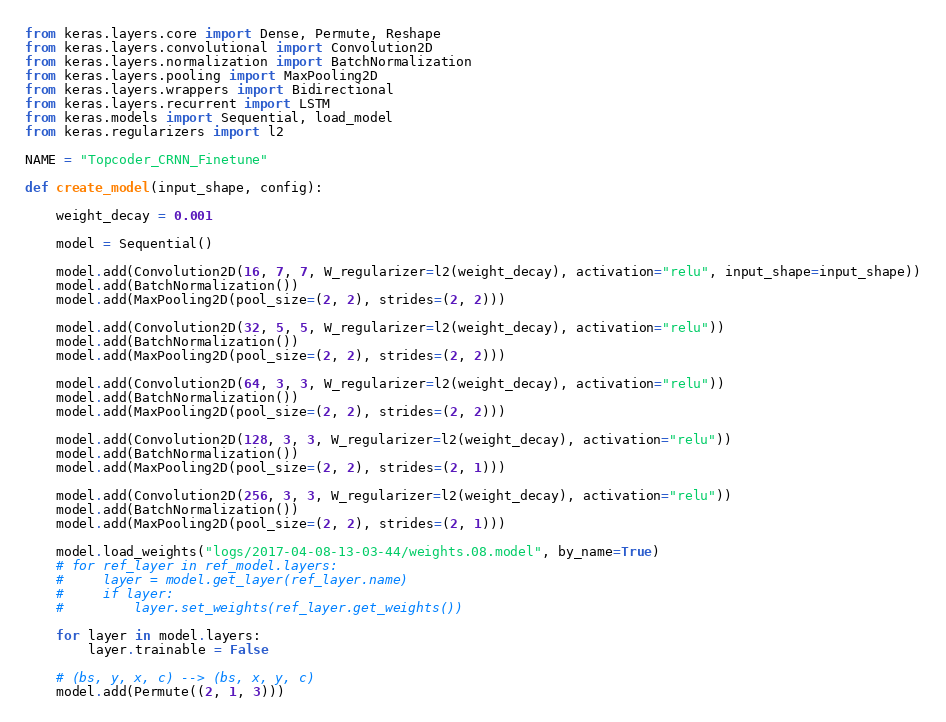Convert code to text. <code><loc_0><loc_0><loc_500><loc_500><_Python_>from keras.layers.core import Dense, Permute, Reshape
from keras.layers.convolutional import Convolution2D
from keras.layers.normalization import BatchNormalization
from keras.layers.pooling import MaxPooling2D
from keras.layers.wrappers import Bidirectional
from keras.layers.recurrent import LSTM
from keras.models import Sequential, load_model
from keras.regularizers import l2

NAME = "Topcoder_CRNN_Finetune"

def create_model(input_shape, config):

    weight_decay = 0.001

    model = Sequential()

    model.add(Convolution2D(16, 7, 7, W_regularizer=l2(weight_decay), activation="relu", input_shape=input_shape))
    model.add(BatchNormalization())
    model.add(MaxPooling2D(pool_size=(2, 2), strides=(2, 2)))

    model.add(Convolution2D(32, 5, 5, W_regularizer=l2(weight_decay), activation="relu"))
    model.add(BatchNormalization())
    model.add(MaxPooling2D(pool_size=(2, 2), strides=(2, 2)))

    model.add(Convolution2D(64, 3, 3, W_regularizer=l2(weight_decay), activation="relu"))
    model.add(BatchNormalization())
    model.add(MaxPooling2D(pool_size=(2, 2), strides=(2, 2)))

    model.add(Convolution2D(128, 3, 3, W_regularizer=l2(weight_decay), activation="relu"))
    model.add(BatchNormalization())
    model.add(MaxPooling2D(pool_size=(2, 2), strides=(2, 1)))

    model.add(Convolution2D(256, 3, 3, W_regularizer=l2(weight_decay), activation="relu"))
    model.add(BatchNormalization())
    model.add(MaxPooling2D(pool_size=(2, 2), strides=(2, 1)))

    model.load_weights("logs/2017-04-08-13-03-44/weights.08.model", by_name=True)
    # for ref_layer in ref_model.layers:
    #     layer = model.get_layer(ref_layer.name)
    #     if layer:
    #         layer.set_weights(ref_layer.get_weights())

    for layer in model.layers:
        layer.trainable = False

    # (bs, y, x, c) --> (bs, x, y, c)
    model.add(Permute((2, 1, 3)))
</code> 